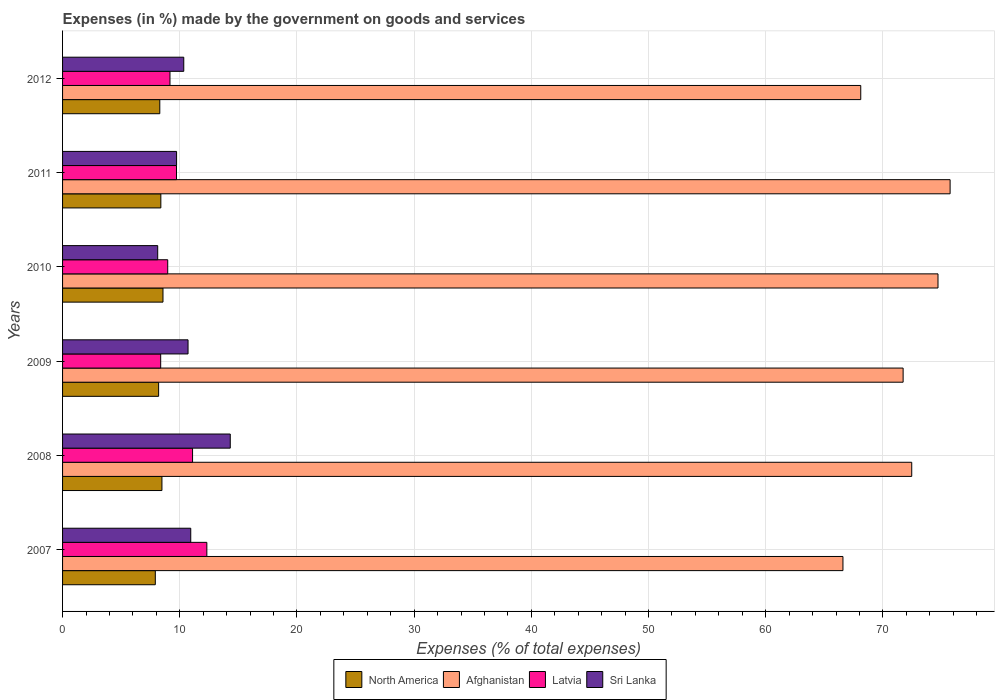How many groups of bars are there?
Keep it short and to the point. 6. Are the number of bars on each tick of the Y-axis equal?
Keep it short and to the point. Yes. How many bars are there on the 3rd tick from the top?
Provide a succinct answer. 4. How many bars are there on the 6th tick from the bottom?
Give a very brief answer. 4. What is the label of the 2nd group of bars from the top?
Offer a very short reply. 2011. What is the percentage of expenses made by the government on goods and services in Latvia in 2007?
Provide a succinct answer. 12.31. Across all years, what is the maximum percentage of expenses made by the government on goods and services in North America?
Keep it short and to the point. 8.57. Across all years, what is the minimum percentage of expenses made by the government on goods and services in Latvia?
Your answer should be very brief. 8.37. In which year was the percentage of expenses made by the government on goods and services in Latvia maximum?
Make the answer very short. 2007. What is the total percentage of expenses made by the government on goods and services in Latvia in the graph?
Make the answer very short. 59.64. What is the difference between the percentage of expenses made by the government on goods and services in Sri Lanka in 2008 and that in 2011?
Make the answer very short. 4.58. What is the difference between the percentage of expenses made by the government on goods and services in Latvia in 2009 and the percentage of expenses made by the government on goods and services in Sri Lanka in 2007?
Your answer should be compact. -2.57. What is the average percentage of expenses made by the government on goods and services in Latvia per year?
Provide a succinct answer. 9.94. In the year 2007, what is the difference between the percentage of expenses made by the government on goods and services in Sri Lanka and percentage of expenses made by the government on goods and services in Afghanistan?
Keep it short and to the point. -55.65. What is the ratio of the percentage of expenses made by the government on goods and services in Latvia in 2008 to that in 2011?
Your response must be concise. 1.14. Is the percentage of expenses made by the government on goods and services in Sri Lanka in 2007 less than that in 2010?
Offer a terse response. No. What is the difference between the highest and the second highest percentage of expenses made by the government on goods and services in Sri Lanka?
Offer a very short reply. 3.37. What is the difference between the highest and the lowest percentage of expenses made by the government on goods and services in Afghanistan?
Provide a succinct answer. 9.14. In how many years, is the percentage of expenses made by the government on goods and services in Afghanistan greater than the average percentage of expenses made by the government on goods and services in Afghanistan taken over all years?
Offer a very short reply. 4. Is it the case that in every year, the sum of the percentage of expenses made by the government on goods and services in Sri Lanka and percentage of expenses made by the government on goods and services in Latvia is greater than the sum of percentage of expenses made by the government on goods and services in North America and percentage of expenses made by the government on goods and services in Afghanistan?
Make the answer very short. No. What does the 4th bar from the top in 2008 represents?
Keep it short and to the point. North America. What does the 1st bar from the bottom in 2010 represents?
Your answer should be compact. North America. How many bars are there?
Your response must be concise. 24. What is the difference between two consecutive major ticks on the X-axis?
Give a very brief answer. 10. Does the graph contain any zero values?
Offer a very short reply. No. Does the graph contain grids?
Your response must be concise. Yes. Where does the legend appear in the graph?
Your response must be concise. Bottom center. How many legend labels are there?
Your answer should be very brief. 4. What is the title of the graph?
Make the answer very short. Expenses (in %) made by the government on goods and services. Does "Arab World" appear as one of the legend labels in the graph?
Offer a terse response. No. What is the label or title of the X-axis?
Your answer should be very brief. Expenses (% of total expenses). What is the label or title of the Y-axis?
Ensure brevity in your answer.  Years. What is the Expenses (% of total expenses) in North America in 2007?
Provide a succinct answer. 7.91. What is the Expenses (% of total expenses) in Afghanistan in 2007?
Give a very brief answer. 66.59. What is the Expenses (% of total expenses) of Latvia in 2007?
Provide a short and direct response. 12.31. What is the Expenses (% of total expenses) in Sri Lanka in 2007?
Your answer should be very brief. 10.94. What is the Expenses (% of total expenses) in North America in 2008?
Provide a short and direct response. 8.48. What is the Expenses (% of total expenses) in Afghanistan in 2008?
Your response must be concise. 72.46. What is the Expenses (% of total expenses) in Latvia in 2008?
Provide a short and direct response. 11.09. What is the Expenses (% of total expenses) in Sri Lanka in 2008?
Offer a very short reply. 14.31. What is the Expenses (% of total expenses) of North America in 2009?
Ensure brevity in your answer.  8.2. What is the Expenses (% of total expenses) in Afghanistan in 2009?
Your response must be concise. 71.72. What is the Expenses (% of total expenses) in Latvia in 2009?
Make the answer very short. 8.37. What is the Expenses (% of total expenses) in Sri Lanka in 2009?
Your answer should be very brief. 10.71. What is the Expenses (% of total expenses) of North America in 2010?
Your response must be concise. 8.57. What is the Expenses (% of total expenses) of Afghanistan in 2010?
Provide a succinct answer. 74.7. What is the Expenses (% of total expenses) in Latvia in 2010?
Your answer should be very brief. 8.97. What is the Expenses (% of total expenses) of Sri Lanka in 2010?
Offer a very short reply. 8.12. What is the Expenses (% of total expenses) in North America in 2011?
Make the answer very short. 8.39. What is the Expenses (% of total expenses) in Afghanistan in 2011?
Provide a succinct answer. 75.73. What is the Expenses (% of total expenses) of Latvia in 2011?
Provide a short and direct response. 9.72. What is the Expenses (% of total expenses) of Sri Lanka in 2011?
Make the answer very short. 9.73. What is the Expenses (% of total expenses) in North America in 2012?
Ensure brevity in your answer.  8.3. What is the Expenses (% of total expenses) of Afghanistan in 2012?
Offer a very short reply. 68.11. What is the Expenses (% of total expenses) of Latvia in 2012?
Your answer should be very brief. 9.17. What is the Expenses (% of total expenses) of Sri Lanka in 2012?
Offer a very short reply. 10.34. Across all years, what is the maximum Expenses (% of total expenses) of North America?
Give a very brief answer. 8.57. Across all years, what is the maximum Expenses (% of total expenses) of Afghanistan?
Offer a very short reply. 75.73. Across all years, what is the maximum Expenses (% of total expenses) in Latvia?
Your response must be concise. 12.31. Across all years, what is the maximum Expenses (% of total expenses) of Sri Lanka?
Your response must be concise. 14.31. Across all years, what is the minimum Expenses (% of total expenses) of North America?
Give a very brief answer. 7.91. Across all years, what is the minimum Expenses (% of total expenses) of Afghanistan?
Make the answer very short. 66.59. Across all years, what is the minimum Expenses (% of total expenses) of Latvia?
Ensure brevity in your answer.  8.37. Across all years, what is the minimum Expenses (% of total expenses) in Sri Lanka?
Your response must be concise. 8.12. What is the total Expenses (% of total expenses) in North America in the graph?
Your answer should be compact. 49.84. What is the total Expenses (% of total expenses) in Afghanistan in the graph?
Give a very brief answer. 429.31. What is the total Expenses (% of total expenses) in Latvia in the graph?
Provide a succinct answer. 59.64. What is the total Expenses (% of total expenses) in Sri Lanka in the graph?
Make the answer very short. 64.14. What is the difference between the Expenses (% of total expenses) in North America in 2007 and that in 2008?
Offer a terse response. -0.57. What is the difference between the Expenses (% of total expenses) in Afghanistan in 2007 and that in 2008?
Your answer should be compact. -5.87. What is the difference between the Expenses (% of total expenses) of Latvia in 2007 and that in 2008?
Make the answer very short. 1.22. What is the difference between the Expenses (% of total expenses) of Sri Lanka in 2007 and that in 2008?
Your response must be concise. -3.37. What is the difference between the Expenses (% of total expenses) in North America in 2007 and that in 2009?
Offer a very short reply. -0.28. What is the difference between the Expenses (% of total expenses) in Afghanistan in 2007 and that in 2009?
Provide a succinct answer. -5.13. What is the difference between the Expenses (% of total expenses) of Latvia in 2007 and that in 2009?
Provide a short and direct response. 3.94. What is the difference between the Expenses (% of total expenses) in Sri Lanka in 2007 and that in 2009?
Make the answer very short. 0.23. What is the difference between the Expenses (% of total expenses) in North America in 2007 and that in 2010?
Offer a very short reply. -0.65. What is the difference between the Expenses (% of total expenses) of Afghanistan in 2007 and that in 2010?
Keep it short and to the point. -8.11. What is the difference between the Expenses (% of total expenses) of Latvia in 2007 and that in 2010?
Your response must be concise. 3.34. What is the difference between the Expenses (% of total expenses) of Sri Lanka in 2007 and that in 2010?
Keep it short and to the point. 2.82. What is the difference between the Expenses (% of total expenses) of North America in 2007 and that in 2011?
Provide a short and direct response. -0.47. What is the difference between the Expenses (% of total expenses) of Afghanistan in 2007 and that in 2011?
Ensure brevity in your answer.  -9.14. What is the difference between the Expenses (% of total expenses) of Latvia in 2007 and that in 2011?
Your answer should be very brief. 2.59. What is the difference between the Expenses (% of total expenses) of Sri Lanka in 2007 and that in 2011?
Your response must be concise. 1.21. What is the difference between the Expenses (% of total expenses) in North America in 2007 and that in 2012?
Your answer should be very brief. -0.38. What is the difference between the Expenses (% of total expenses) in Afghanistan in 2007 and that in 2012?
Offer a terse response. -1.52. What is the difference between the Expenses (% of total expenses) in Latvia in 2007 and that in 2012?
Your response must be concise. 3.15. What is the difference between the Expenses (% of total expenses) in Sri Lanka in 2007 and that in 2012?
Make the answer very short. 0.6. What is the difference between the Expenses (% of total expenses) in North America in 2008 and that in 2009?
Offer a very short reply. 0.28. What is the difference between the Expenses (% of total expenses) in Afghanistan in 2008 and that in 2009?
Your answer should be compact. 0.73. What is the difference between the Expenses (% of total expenses) in Latvia in 2008 and that in 2009?
Provide a succinct answer. 2.72. What is the difference between the Expenses (% of total expenses) of Sri Lanka in 2008 and that in 2009?
Your answer should be compact. 3.6. What is the difference between the Expenses (% of total expenses) in North America in 2008 and that in 2010?
Offer a very short reply. -0.09. What is the difference between the Expenses (% of total expenses) of Afghanistan in 2008 and that in 2010?
Offer a very short reply. -2.24. What is the difference between the Expenses (% of total expenses) in Latvia in 2008 and that in 2010?
Provide a succinct answer. 2.12. What is the difference between the Expenses (% of total expenses) in Sri Lanka in 2008 and that in 2010?
Your answer should be very brief. 6.19. What is the difference between the Expenses (% of total expenses) in North America in 2008 and that in 2011?
Offer a very short reply. 0.09. What is the difference between the Expenses (% of total expenses) in Afghanistan in 2008 and that in 2011?
Offer a terse response. -3.27. What is the difference between the Expenses (% of total expenses) in Latvia in 2008 and that in 2011?
Your answer should be compact. 1.37. What is the difference between the Expenses (% of total expenses) in Sri Lanka in 2008 and that in 2011?
Your answer should be compact. 4.58. What is the difference between the Expenses (% of total expenses) in North America in 2008 and that in 2012?
Your response must be concise. 0.18. What is the difference between the Expenses (% of total expenses) in Afghanistan in 2008 and that in 2012?
Your answer should be compact. 4.35. What is the difference between the Expenses (% of total expenses) of Latvia in 2008 and that in 2012?
Ensure brevity in your answer.  1.93. What is the difference between the Expenses (% of total expenses) of Sri Lanka in 2008 and that in 2012?
Provide a short and direct response. 3.97. What is the difference between the Expenses (% of total expenses) of North America in 2009 and that in 2010?
Offer a terse response. -0.37. What is the difference between the Expenses (% of total expenses) of Afghanistan in 2009 and that in 2010?
Ensure brevity in your answer.  -2.98. What is the difference between the Expenses (% of total expenses) of Latvia in 2009 and that in 2010?
Offer a very short reply. -0.6. What is the difference between the Expenses (% of total expenses) of Sri Lanka in 2009 and that in 2010?
Your answer should be very brief. 2.59. What is the difference between the Expenses (% of total expenses) in North America in 2009 and that in 2011?
Keep it short and to the point. -0.19. What is the difference between the Expenses (% of total expenses) in Afghanistan in 2009 and that in 2011?
Provide a succinct answer. -4.01. What is the difference between the Expenses (% of total expenses) in Latvia in 2009 and that in 2011?
Provide a succinct answer. -1.35. What is the difference between the Expenses (% of total expenses) in Sri Lanka in 2009 and that in 2011?
Provide a succinct answer. 0.98. What is the difference between the Expenses (% of total expenses) of North America in 2009 and that in 2012?
Your answer should be very brief. -0.1. What is the difference between the Expenses (% of total expenses) in Afghanistan in 2009 and that in 2012?
Give a very brief answer. 3.62. What is the difference between the Expenses (% of total expenses) of Latvia in 2009 and that in 2012?
Offer a terse response. -0.79. What is the difference between the Expenses (% of total expenses) in Sri Lanka in 2009 and that in 2012?
Provide a succinct answer. 0.36. What is the difference between the Expenses (% of total expenses) of North America in 2010 and that in 2011?
Provide a short and direct response. 0.18. What is the difference between the Expenses (% of total expenses) in Afghanistan in 2010 and that in 2011?
Provide a short and direct response. -1.03. What is the difference between the Expenses (% of total expenses) of Latvia in 2010 and that in 2011?
Your answer should be very brief. -0.75. What is the difference between the Expenses (% of total expenses) of Sri Lanka in 2010 and that in 2011?
Give a very brief answer. -1.61. What is the difference between the Expenses (% of total expenses) in North America in 2010 and that in 2012?
Your answer should be compact. 0.27. What is the difference between the Expenses (% of total expenses) of Afghanistan in 2010 and that in 2012?
Offer a terse response. 6.59. What is the difference between the Expenses (% of total expenses) of Latvia in 2010 and that in 2012?
Ensure brevity in your answer.  -0.19. What is the difference between the Expenses (% of total expenses) of Sri Lanka in 2010 and that in 2012?
Provide a succinct answer. -2.22. What is the difference between the Expenses (% of total expenses) in North America in 2011 and that in 2012?
Your answer should be compact. 0.09. What is the difference between the Expenses (% of total expenses) of Afghanistan in 2011 and that in 2012?
Make the answer very short. 7.63. What is the difference between the Expenses (% of total expenses) in Latvia in 2011 and that in 2012?
Offer a terse response. 0.56. What is the difference between the Expenses (% of total expenses) of Sri Lanka in 2011 and that in 2012?
Provide a short and direct response. -0.61. What is the difference between the Expenses (% of total expenses) of North America in 2007 and the Expenses (% of total expenses) of Afghanistan in 2008?
Ensure brevity in your answer.  -64.54. What is the difference between the Expenses (% of total expenses) in North America in 2007 and the Expenses (% of total expenses) in Latvia in 2008?
Your response must be concise. -3.18. What is the difference between the Expenses (% of total expenses) in North America in 2007 and the Expenses (% of total expenses) in Sri Lanka in 2008?
Provide a succinct answer. -6.39. What is the difference between the Expenses (% of total expenses) in Afghanistan in 2007 and the Expenses (% of total expenses) in Latvia in 2008?
Offer a very short reply. 55.5. What is the difference between the Expenses (% of total expenses) in Afghanistan in 2007 and the Expenses (% of total expenses) in Sri Lanka in 2008?
Offer a very short reply. 52.28. What is the difference between the Expenses (% of total expenses) in Latvia in 2007 and the Expenses (% of total expenses) in Sri Lanka in 2008?
Provide a short and direct response. -2. What is the difference between the Expenses (% of total expenses) in North America in 2007 and the Expenses (% of total expenses) in Afghanistan in 2009?
Offer a terse response. -63.81. What is the difference between the Expenses (% of total expenses) in North America in 2007 and the Expenses (% of total expenses) in Latvia in 2009?
Your answer should be very brief. -0.46. What is the difference between the Expenses (% of total expenses) of North America in 2007 and the Expenses (% of total expenses) of Sri Lanka in 2009?
Provide a succinct answer. -2.79. What is the difference between the Expenses (% of total expenses) in Afghanistan in 2007 and the Expenses (% of total expenses) in Latvia in 2009?
Provide a succinct answer. 58.22. What is the difference between the Expenses (% of total expenses) of Afghanistan in 2007 and the Expenses (% of total expenses) of Sri Lanka in 2009?
Your answer should be compact. 55.88. What is the difference between the Expenses (% of total expenses) of Latvia in 2007 and the Expenses (% of total expenses) of Sri Lanka in 2009?
Your answer should be compact. 1.6. What is the difference between the Expenses (% of total expenses) in North America in 2007 and the Expenses (% of total expenses) in Afghanistan in 2010?
Make the answer very short. -66.79. What is the difference between the Expenses (% of total expenses) in North America in 2007 and the Expenses (% of total expenses) in Latvia in 2010?
Make the answer very short. -1.06. What is the difference between the Expenses (% of total expenses) in North America in 2007 and the Expenses (% of total expenses) in Sri Lanka in 2010?
Provide a short and direct response. -0.2. What is the difference between the Expenses (% of total expenses) in Afghanistan in 2007 and the Expenses (% of total expenses) in Latvia in 2010?
Keep it short and to the point. 57.62. What is the difference between the Expenses (% of total expenses) of Afghanistan in 2007 and the Expenses (% of total expenses) of Sri Lanka in 2010?
Your answer should be compact. 58.47. What is the difference between the Expenses (% of total expenses) in Latvia in 2007 and the Expenses (% of total expenses) in Sri Lanka in 2010?
Offer a very short reply. 4.19. What is the difference between the Expenses (% of total expenses) of North America in 2007 and the Expenses (% of total expenses) of Afghanistan in 2011?
Give a very brief answer. -67.82. What is the difference between the Expenses (% of total expenses) of North America in 2007 and the Expenses (% of total expenses) of Latvia in 2011?
Make the answer very short. -1.81. What is the difference between the Expenses (% of total expenses) in North America in 2007 and the Expenses (% of total expenses) in Sri Lanka in 2011?
Provide a short and direct response. -1.81. What is the difference between the Expenses (% of total expenses) in Afghanistan in 2007 and the Expenses (% of total expenses) in Latvia in 2011?
Your answer should be compact. 56.87. What is the difference between the Expenses (% of total expenses) of Afghanistan in 2007 and the Expenses (% of total expenses) of Sri Lanka in 2011?
Keep it short and to the point. 56.86. What is the difference between the Expenses (% of total expenses) of Latvia in 2007 and the Expenses (% of total expenses) of Sri Lanka in 2011?
Your response must be concise. 2.58. What is the difference between the Expenses (% of total expenses) of North America in 2007 and the Expenses (% of total expenses) of Afghanistan in 2012?
Your answer should be very brief. -60.19. What is the difference between the Expenses (% of total expenses) of North America in 2007 and the Expenses (% of total expenses) of Latvia in 2012?
Make the answer very short. -1.25. What is the difference between the Expenses (% of total expenses) of North America in 2007 and the Expenses (% of total expenses) of Sri Lanka in 2012?
Keep it short and to the point. -2.43. What is the difference between the Expenses (% of total expenses) in Afghanistan in 2007 and the Expenses (% of total expenses) in Latvia in 2012?
Your response must be concise. 57.42. What is the difference between the Expenses (% of total expenses) of Afghanistan in 2007 and the Expenses (% of total expenses) of Sri Lanka in 2012?
Your answer should be compact. 56.25. What is the difference between the Expenses (% of total expenses) in Latvia in 2007 and the Expenses (% of total expenses) in Sri Lanka in 2012?
Your response must be concise. 1.97. What is the difference between the Expenses (% of total expenses) of North America in 2008 and the Expenses (% of total expenses) of Afghanistan in 2009?
Provide a succinct answer. -63.24. What is the difference between the Expenses (% of total expenses) in North America in 2008 and the Expenses (% of total expenses) in Latvia in 2009?
Provide a succinct answer. 0.11. What is the difference between the Expenses (% of total expenses) of North America in 2008 and the Expenses (% of total expenses) of Sri Lanka in 2009?
Ensure brevity in your answer.  -2.23. What is the difference between the Expenses (% of total expenses) of Afghanistan in 2008 and the Expenses (% of total expenses) of Latvia in 2009?
Your response must be concise. 64.09. What is the difference between the Expenses (% of total expenses) in Afghanistan in 2008 and the Expenses (% of total expenses) in Sri Lanka in 2009?
Give a very brief answer. 61.75. What is the difference between the Expenses (% of total expenses) of Latvia in 2008 and the Expenses (% of total expenses) of Sri Lanka in 2009?
Provide a succinct answer. 0.39. What is the difference between the Expenses (% of total expenses) in North America in 2008 and the Expenses (% of total expenses) in Afghanistan in 2010?
Your answer should be very brief. -66.22. What is the difference between the Expenses (% of total expenses) of North America in 2008 and the Expenses (% of total expenses) of Latvia in 2010?
Offer a very short reply. -0.49. What is the difference between the Expenses (% of total expenses) of North America in 2008 and the Expenses (% of total expenses) of Sri Lanka in 2010?
Keep it short and to the point. 0.36. What is the difference between the Expenses (% of total expenses) in Afghanistan in 2008 and the Expenses (% of total expenses) in Latvia in 2010?
Offer a terse response. 63.49. What is the difference between the Expenses (% of total expenses) in Afghanistan in 2008 and the Expenses (% of total expenses) in Sri Lanka in 2010?
Your answer should be compact. 64.34. What is the difference between the Expenses (% of total expenses) in Latvia in 2008 and the Expenses (% of total expenses) in Sri Lanka in 2010?
Offer a very short reply. 2.97. What is the difference between the Expenses (% of total expenses) of North America in 2008 and the Expenses (% of total expenses) of Afghanistan in 2011?
Your answer should be compact. -67.25. What is the difference between the Expenses (% of total expenses) in North America in 2008 and the Expenses (% of total expenses) in Latvia in 2011?
Provide a short and direct response. -1.24. What is the difference between the Expenses (% of total expenses) in North America in 2008 and the Expenses (% of total expenses) in Sri Lanka in 2011?
Offer a very short reply. -1.25. What is the difference between the Expenses (% of total expenses) of Afghanistan in 2008 and the Expenses (% of total expenses) of Latvia in 2011?
Your response must be concise. 62.74. What is the difference between the Expenses (% of total expenses) in Afghanistan in 2008 and the Expenses (% of total expenses) in Sri Lanka in 2011?
Offer a very short reply. 62.73. What is the difference between the Expenses (% of total expenses) in Latvia in 2008 and the Expenses (% of total expenses) in Sri Lanka in 2011?
Provide a short and direct response. 1.36. What is the difference between the Expenses (% of total expenses) in North America in 2008 and the Expenses (% of total expenses) in Afghanistan in 2012?
Give a very brief answer. -59.63. What is the difference between the Expenses (% of total expenses) of North America in 2008 and the Expenses (% of total expenses) of Latvia in 2012?
Make the answer very short. -0.69. What is the difference between the Expenses (% of total expenses) in North America in 2008 and the Expenses (% of total expenses) in Sri Lanka in 2012?
Make the answer very short. -1.86. What is the difference between the Expenses (% of total expenses) of Afghanistan in 2008 and the Expenses (% of total expenses) of Latvia in 2012?
Offer a very short reply. 63.29. What is the difference between the Expenses (% of total expenses) of Afghanistan in 2008 and the Expenses (% of total expenses) of Sri Lanka in 2012?
Offer a very short reply. 62.12. What is the difference between the Expenses (% of total expenses) of Latvia in 2008 and the Expenses (% of total expenses) of Sri Lanka in 2012?
Provide a short and direct response. 0.75. What is the difference between the Expenses (% of total expenses) in North America in 2009 and the Expenses (% of total expenses) in Afghanistan in 2010?
Your answer should be compact. -66.5. What is the difference between the Expenses (% of total expenses) of North America in 2009 and the Expenses (% of total expenses) of Latvia in 2010?
Give a very brief answer. -0.78. What is the difference between the Expenses (% of total expenses) of North America in 2009 and the Expenses (% of total expenses) of Sri Lanka in 2010?
Keep it short and to the point. 0.08. What is the difference between the Expenses (% of total expenses) of Afghanistan in 2009 and the Expenses (% of total expenses) of Latvia in 2010?
Keep it short and to the point. 62.75. What is the difference between the Expenses (% of total expenses) of Afghanistan in 2009 and the Expenses (% of total expenses) of Sri Lanka in 2010?
Your answer should be compact. 63.61. What is the difference between the Expenses (% of total expenses) of Latvia in 2009 and the Expenses (% of total expenses) of Sri Lanka in 2010?
Your answer should be compact. 0.26. What is the difference between the Expenses (% of total expenses) in North America in 2009 and the Expenses (% of total expenses) in Afghanistan in 2011?
Give a very brief answer. -67.54. What is the difference between the Expenses (% of total expenses) of North America in 2009 and the Expenses (% of total expenses) of Latvia in 2011?
Offer a very short reply. -1.53. What is the difference between the Expenses (% of total expenses) of North America in 2009 and the Expenses (% of total expenses) of Sri Lanka in 2011?
Keep it short and to the point. -1.53. What is the difference between the Expenses (% of total expenses) of Afghanistan in 2009 and the Expenses (% of total expenses) of Latvia in 2011?
Your answer should be compact. 62. What is the difference between the Expenses (% of total expenses) of Afghanistan in 2009 and the Expenses (% of total expenses) of Sri Lanka in 2011?
Your answer should be very brief. 62. What is the difference between the Expenses (% of total expenses) in Latvia in 2009 and the Expenses (% of total expenses) in Sri Lanka in 2011?
Your answer should be compact. -1.36. What is the difference between the Expenses (% of total expenses) of North America in 2009 and the Expenses (% of total expenses) of Afghanistan in 2012?
Your response must be concise. -59.91. What is the difference between the Expenses (% of total expenses) of North America in 2009 and the Expenses (% of total expenses) of Latvia in 2012?
Keep it short and to the point. -0.97. What is the difference between the Expenses (% of total expenses) of North America in 2009 and the Expenses (% of total expenses) of Sri Lanka in 2012?
Your response must be concise. -2.15. What is the difference between the Expenses (% of total expenses) of Afghanistan in 2009 and the Expenses (% of total expenses) of Latvia in 2012?
Your response must be concise. 62.56. What is the difference between the Expenses (% of total expenses) of Afghanistan in 2009 and the Expenses (% of total expenses) of Sri Lanka in 2012?
Your answer should be compact. 61.38. What is the difference between the Expenses (% of total expenses) in Latvia in 2009 and the Expenses (% of total expenses) in Sri Lanka in 2012?
Your answer should be compact. -1.97. What is the difference between the Expenses (% of total expenses) in North America in 2010 and the Expenses (% of total expenses) in Afghanistan in 2011?
Offer a very short reply. -67.16. What is the difference between the Expenses (% of total expenses) of North America in 2010 and the Expenses (% of total expenses) of Latvia in 2011?
Your answer should be compact. -1.15. What is the difference between the Expenses (% of total expenses) of North America in 2010 and the Expenses (% of total expenses) of Sri Lanka in 2011?
Offer a very short reply. -1.16. What is the difference between the Expenses (% of total expenses) in Afghanistan in 2010 and the Expenses (% of total expenses) in Latvia in 2011?
Offer a very short reply. 64.98. What is the difference between the Expenses (% of total expenses) in Afghanistan in 2010 and the Expenses (% of total expenses) in Sri Lanka in 2011?
Offer a very short reply. 64.97. What is the difference between the Expenses (% of total expenses) in Latvia in 2010 and the Expenses (% of total expenses) in Sri Lanka in 2011?
Your answer should be compact. -0.76. What is the difference between the Expenses (% of total expenses) in North America in 2010 and the Expenses (% of total expenses) in Afghanistan in 2012?
Your answer should be very brief. -59.54. What is the difference between the Expenses (% of total expenses) of North America in 2010 and the Expenses (% of total expenses) of Latvia in 2012?
Ensure brevity in your answer.  -0.6. What is the difference between the Expenses (% of total expenses) in North America in 2010 and the Expenses (% of total expenses) in Sri Lanka in 2012?
Keep it short and to the point. -1.77. What is the difference between the Expenses (% of total expenses) in Afghanistan in 2010 and the Expenses (% of total expenses) in Latvia in 2012?
Make the answer very short. 65.53. What is the difference between the Expenses (% of total expenses) of Afghanistan in 2010 and the Expenses (% of total expenses) of Sri Lanka in 2012?
Provide a succinct answer. 64.36. What is the difference between the Expenses (% of total expenses) of Latvia in 2010 and the Expenses (% of total expenses) of Sri Lanka in 2012?
Your answer should be compact. -1.37. What is the difference between the Expenses (% of total expenses) of North America in 2011 and the Expenses (% of total expenses) of Afghanistan in 2012?
Provide a succinct answer. -59.72. What is the difference between the Expenses (% of total expenses) in North America in 2011 and the Expenses (% of total expenses) in Latvia in 2012?
Offer a very short reply. -0.78. What is the difference between the Expenses (% of total expenses) in North America in 2011 and the Expenses (% of total expenses) in Sri Lanka in 2012?
Give a very brief answer. -1.96. What is the difference between the Expenses (% of total expenses) in Afghanistan in 2011 and the Expenses (% of total expenses) in Latvia in 2012?
Your answer should be very brief. 66.57. What is the difference between the Expenses (% of total expenses) in Afghanistan in 2011 and the Expenses (% of total expenses) in Sri Lanka in 2012?
Give a very brief answer. 65.39. What is the difference between the Expenses (% of total expenses) of Latvia in 2011 and the Expenses (% of total expenses) of Sri Lanka in 2012?
Provide a short and direct response. -0.62. What is the average Expenses (% of total expenses) in North America per year?
Your answer should be very brief. 8.31. What is the average Expenses (% of total expenses) of Afghanistan per year?
Provide a succinct answer. 71.55. What is the average Expenses (% of total expenses) in Latvia per year?
Keep it short and to the point. 9.94. What is the average Expenses (% of total expenses) in Sri Lanka per year?
Your answer should be very brief. 10.69. In the year 2007, what is the difference between the Expenses (% of total expenses) in North America and Expenses (% of total expenses) in Afghanistan?
Ensure brevity in your answer.  -58.68. In the year 2007, what is the difference between the Expenses (% of total expenses) of North America and Expenses (% of total expenses) of Latvia?
Give a very brief answer. -4.4. In the year 2007, what is the difference between the Expenses (% of total expenses) in North America and Expenses (% of total expenses) in Sri Lanka?
Ensure brevity in your answer.  -3.02. In the year 2007, what is the difference between the Expenses (% of total expenses) of Afghanistan and Expenses (% of total expenses) of Latvia?
Make the answer very short. 54.28. In the year 2007, what is the difference between the Expenses (% of total expenses) of Afghanistan and Expenses (% of total expenses) of Sri Lanka?
Provide a short and direct response. 55.65. In the year 2007, what is the difference between the Expenses (% of total expenses) in Latvia and Expenses (% of total expenses) in Sri Lanka?
Provide a short and direct response. 1.37. In the year 2008, what is the difference between the Expenses (% of total expenses) of North America and Expenses (% of total expenses) of Afghanistan?
Keep it short and to the point. -63.98. In the year 2008, what is the difference between the Expenses (% of total expenses) of North America and Expenses (% of total expenses) of Latvia?
Your answer should be compact. -2.61. In the year 2008, what is the difference between the Expenses (% of total expenses) of North America and Expenses (% of total expenses) of Sri Lanka?
Your answer should be compact. -5.83. In the year 2008, what is the difference between the Expenses (% of total expenses) of Afghanistan and Expenses (% of total expenses) of Latvia?
Keep it short and to the point. 61.37. In the year 2008, what is the difference between the Expenses (% of total expenses) in Afghanistan and Expenses (% of total expenses) in Sri Lanka?
Your answer should be very brief. 58.15. In the year 2008, what is the difference between the Expenses (% of total expenses) in Latvia and Expenses (% of total expenses) in Sri Lanka?
Keep it short and to the point. -3.22. In the year 2009, what is the difference between the Expenses (% of total expenses) of North America and Expenses (% of total expenses) of Afghanistan?
Give a very brief answer. -63.53. In the year 2009, what is the difference between the Expenses (% of total expenses) of North America and Expenses (% of total expenses) of Latvia?
Provide a short and direct response. -0.18. In the year 2009, what is the difference between the Expenses (% of total expenses) in North America and Expenses (% of total expenses) in Sri Lanka?
Your answer should be very brief. -2.51. In the year 2009, what is the difference between the Expenses (% of total expenses) in Afghanistan and Expenses (% of total expenses) in Latvia?
Make the answer very short. 63.35. In the year 2009, what is the difference between the Expenses (% of total expenses) of Afghanistan and Expenses (% of total expenses) of Sri Lanka?
Your answer should be compact. 61.02. In the year 2009, what is the difference between the Expenses (% of total expenses) in Latvia and Expenses (% of total expenses) in Sri Lanka?
Keep it short and to the point. -2.33. In the year 2010, what is the difference between the Expenses (% of total expenses) in North America and Expenses (% of total expenses) in Afghanistan?
Your answer should be very brief. -66.13. In the year 2010, what is the difference between the Expenses (% of total expenses) of North America and Expenses (% of total expenses) of Latvia?
Offer a terse response. -0.4. In the year 2010, what is the difference between the Expenses (% of total expenses) in North America and Expenses (% of total expenses) in Sri Lanka?
Keep it short and to the point. 0.45. In the year 2010, what is the difference between the Expenses (% of total expenses) in Afghanistan and Expenses (% of total expenses) in Latvia?
Provide a succinct answer. 65.73. In the year 2010, what is the difference between the Expenses (% of total expenses) of Afghanistan and Expenses (% of total expenses) of Sri Lanka?
Give a very brief answer. 66.58. In the year 2010, what is the difference between the Expenses (% of total expenses) of Latvia and Expenses (% of total expenses) of Sri Lanka?
Ensure brevity in your answer.  0.86. In the year 2011, what is the difference between the Expenses (% of total expenses) in North America and Expenses (% of total expenses) in Afghanistan?
Give a very brief answer. -67.35. In the year 2011, what is the difference between the Expenses (% of total expenses) of North America and Expenses (% of total expenses) of Latvia?
Offer a very short reply. -1.34. In the year 2011, what is the difference between the Expenses (% of total expenses) of North America and Expenses (% of total expenses) of Sri Lanka?
Provide a succinct answer. -1.34. In the year 2011, what is the difference between the Expenses (% of total expenses) in Afghanistan and Expenses (% of total expenses) in Latvia?
Your answer should be compact. 66.01. In the year 2011, what is the difference between the Expenses (% of total expenses) in Afghanistan and Expenses (% of total expenses) in Sri Lanka?
Provide a short and direct response. 66. In the year 2011, what is the difference between the Expenses (% of total expenses) of Latvia and Expenses (% of total expenses) of Sri Lanka?
Your answer should be very brief. -0.01. In the year 2012, what is the difference between the Expenses (% of total expenses) in North America and Expenses (% of total expenses) in Afghanistan?
Ensure brevity in your answer.  -59.81. In the year 2012, what is the difference between the Expenses (% of total expenses) in North America and Expenses (% of total expenses) in Latvia?
Offer a terse response. -0.87. In the year 2012, what is the difference between the Expenses (% of total expenses) of North America and Expenses (% of total expenses) of Sri Lanka?
Offer a terse response. -2.04. In the year 2012, what is the difference between the Expenses (% of total expenses) of Afghanistan and Expenses (% of total expenses) of Latvia?
Make the answer very short. 58.94. In the year 2012, what is the difference between the Expenses (% of total expenses) in Afghanistan and Expenses (% of total expenses) in Sri Lanka?
Provide a short and direct response. 57.77. In the year 2012, what is the difference between the Expenses (% of total expenses) of Latvia and Expenses (% of total expenses) of Sri Lanka?
Ensure brevity in your answer.  -1.18. What is the ratio of the Expenses (% of total expenses) in Afghanistan in 2007 to that in 2008?
Your response must be concise. 0.92. What is the ratio of the Expenses (% of total expenses) of Latvia in 2007 to that in 2008?
Your answer should be compact. 1.11. What is the ratio of the Expenses (% of total expenses) in Sri Lanka in 2007 to that in 2008?
Your response must be concise. 0.76. What is the ratio of the Expenses (% of total expenses) of North America in 2007 to that in 2009?
Provide a short and direct response. 0.97. What is the ratio of the Expenses (% of total expenses) of Afghanistan in 2007 to that in 2009?
Your answer should be compact. 0.93. What is the ratio of the Expenses (% of total expenses) in Latvia in 2007 to that in 2009?
Ensure brevity in your answer.  1.47. What is the ratio of the Expenses (% of total expenses) in Sri Lanka in 2007 to that in 2009?
Your answer should be compact. 1.02. What is the ratio of the Expenses (% of total expenses) in North America in 2007 to that in 2010?
Offer a terse response. 0.92. What is the ratio of the Expenses (% of total expenses) of Afghanistan in 2007 to that in 2010?
Offer a very short reply. 0.89. What is the ratio of the Expenses (% of total expenses) of Latvia in 2007 to that in 2010?
Give a very brief answer. 1.37. What is the ratio of the Expenses (% of total expenses) in Sri Lanka in 2007 to that in 2010?
Your answer should be very brief. 1.35. What is the ratio of the Expenses (% of total expenses) in North America in 2007 to that in 2011?
Provide a succinct answer. 0.94. What is the ratio of the Expenses (% of total expenses) in Afghanistan in 2007 to that in 2011?
Make the answer very short. 0.88. What is the ratio of the Expenses (% of total expenses) in Latvia in 2007 to that in 2011?
Provide a succinct answer. 1.27. What is the ratio of the Expenses (% of total expenses) in Sri Lanka in 2007 to that in 2011?
Your answer should be very brief. 1.12. What is the ratio of the Expenses (% of total expenses) of North America in 2007 to that in 2012?
Your answer should be very brief. 0.95. What is the ratio of the Expenses (% of total expenses) of Afghanistan in 2007 to that in 2012?
Your answer should be compact. 0.98. What is the ratio of the Expenses (% of total expenses) in Latvia in 2007 to that in 2012?
Give a very brief answer. 1.34. What is the ratio of the Expenses (% of total expenses) of Sri Lanka in 2007 to that in 2012?
Give a very brief answer. 1.06. What is the ratio of the Expenses (% of total expenses) of North America in 2008 to that in 2009?
Your answer should be very brief. 1.03. What is the ratio of the Expenses (% of total expenses) in Afghanistan in 2008 to that in 2009?
Ensure brevity in your answer.  1.01. What is the ratio of the Expenses (% of total expenses) in Latvia in 2008 to that in 2009?
Offer a terse response. 1.32. What is the ratio of the Expenses (% of total expenses) in Sri Lanka in 2008 to that in 2009?
Provide a succinct answer. 1.34. What is the ratio of the Expenses (% of total expenses) in Latvia in 2008 to that in 2010?
Keep it short and to the point. 1.24. What is the ratio of the Expenses (% of total expenses) in Sri Lanka in 2008 to that in 2010?
Your answer should be very brief. 1.76. What is the ratio of the Expenses (% of total expenses) of North America in 2008 to that in 2011?
Keep it short and to the point. 1.01. What is the ratio of the Expenses (% of total expenses) in Afghanistan in 2008 to that in 2011?
Offer a terse response. 0.96. What is the ratio of the Expenses (% of total expenses) of Latvia in 2008 to that in 2011?
Your answer should be compact. 1.14. What is the ratio of the Expenses (% of total expenses) of Sri Lanka in 2008 to that in 2011?
Offer a very short reply. 1.47. What is the ratio of the Expenses (% of total expenses) of North America in 2008 to that in 2012?
Provide a succinct answer. 1.02. What is the ratio of the Expenses (% of total expenses) of Afghanistan in 2008 to that in 2012?
Offer a terse response. 1.06. What is the ratio of the Expenses (% of total expenses) in Latvia in 2008 to that in 2012?
Your answer should be very brief. 1.21. What is the ratio of the Expenses (% of total expenses) of Sri Lanka in 2008 to that in 2012?
Your response must be concise. 1.38. What is the ratio of the Expenses (% of total expenses) of North America in 2009 to that in 2010?
Provide a short and direct response. 0.96. What is the ratio of the Expenses (% of total expenses) of Afghanistan in 2009 to that in 2010?
Give a very brief answer. 0.96. What is the ratio of the Expenses (% of total expenses) of Latvia in 2009 to that in 2010?
Keep it short and to the point. 0.93. What is the ratio of the Expenses (% of total expenses) of Sri Lanka in 2009 to that in 2010?
Offer a very short reply. 1.32. What is the ratio of the Expenses (% of total expenses) of North America in 2009 to that in 2011?
Provide a succinct answer. 0.98. What is the ratio of the Expenses (% of total expenses) in Afghanistan in 2009 to that in 2011?
Your answer should be very brief. 0.95. What is the ratio of the Expenses (% of total expenses) in Latvia in 2009 to that in 2011?
Provide a succinct answer. 0.86. What is the ratio of the Expenses (% of total expenses) in Sri Lanka in 2009 to that in 2011?
Ensure brevity in your answer.  1.1. What is the ratio of the Expenses (% of total expenses) in North America in 2009 to that in 2012?
Provide a short and direct response. 0.99. What is the ratio of the Expenses (% of total expenses) in Afghanistan in 2009 to that in 2012?
Ensure brevity in your answer.  1.05. What is the ratio of the Expenses (% of total expenses) of Latvia in 2009 to that in 2012?
Make the answer very short. 0.91. What is the ratio of the Expenses (% of total expenses) in Sri Lanka in 2009 to that in 2012?
Your response must be concise. 1.04. What is the ratio of the Expenses (% of total expenses) in North America in 2010 to that in 2011?
Offer a very short reply. 1.02. What is the ratio of the Expenses (% of total expenses) in Afghanistan in 2010 to that in 2011?
Offer a terse response. 0.99. What is the ratio of the Expenses (% of total expenses) of Latvia in 2010 to that in 2011?
Provide a succinct answer. 0.92. What is the ratio of the Expenses (% of total expenses) of Sri Lanka in 2010 to that in 2011?
Give a very brief answer. 0.83. What is the ratio of the Expenses (% of total expenses) of North America in 2010 to that in 2012?
Provide a short and direct response. 1.03. What is the ratio of the Expenses (% of total expenses) of Afghanistan in 2010 to that in 2012?
Provide a short and direct response. 1.1. What is the ratio of the Expenses (% of total expenses) of Sri Lanka in 2010 to that in 2012?
Give a very brief answer. 0.78. What is the ratio of the Expenses (% of total expenses) in North America in 2011 to that in 2012?
Your response must be concise. 1.01. What is the ratio of the Expenses (% of total expenses) of Afghanistan in 2011 to that in 2012?
Your response must be concise. 1.11. What is the ratio of the Expenses (% of total expenses) in Latvia in 2011 to that in 2012?
Ensure brevity in your answer.  1.06. What is the ratio of the Expenses (% of total expenses) of Sri Lanka in 2011 to that in 2012?
Give a very brief answer. 0.94. What is the difference between the highest and the second highest Expenses (% of total expenses) of North America?
Your response must be concise. 0.09. What is the difference between the highest and the second highest Expenses (% of total expenses) in Afghanistan?
Your response must be concise. 1.03. What is the difference between the highest and the second highest Expenses (% of total expenses) of Latvia?
Provide a succinct answer. 1.22. What is the difference between the highest and the second highest Expenses (% of total expenses) of Sri Lanka?
Give a very brief answer. 3.37. What is the difference between the highest and the lowest Expenses (% of total expenses) in North America?
Your response must be concise. 0.65. What is the difference between the highest and the lowest Expenses (% of total expenses) in Afghanistan?
Ensure brevity in your answer.  9.14. What is the difference between the highest and the lowest Expenses (% of total expenses) in Latvia?
Make the answer very short. 3.94. What is the difference between the highest and the lowest Expenses (% of total expenses) of Sri Lanka?
Give a very brief answer. 6.19. 